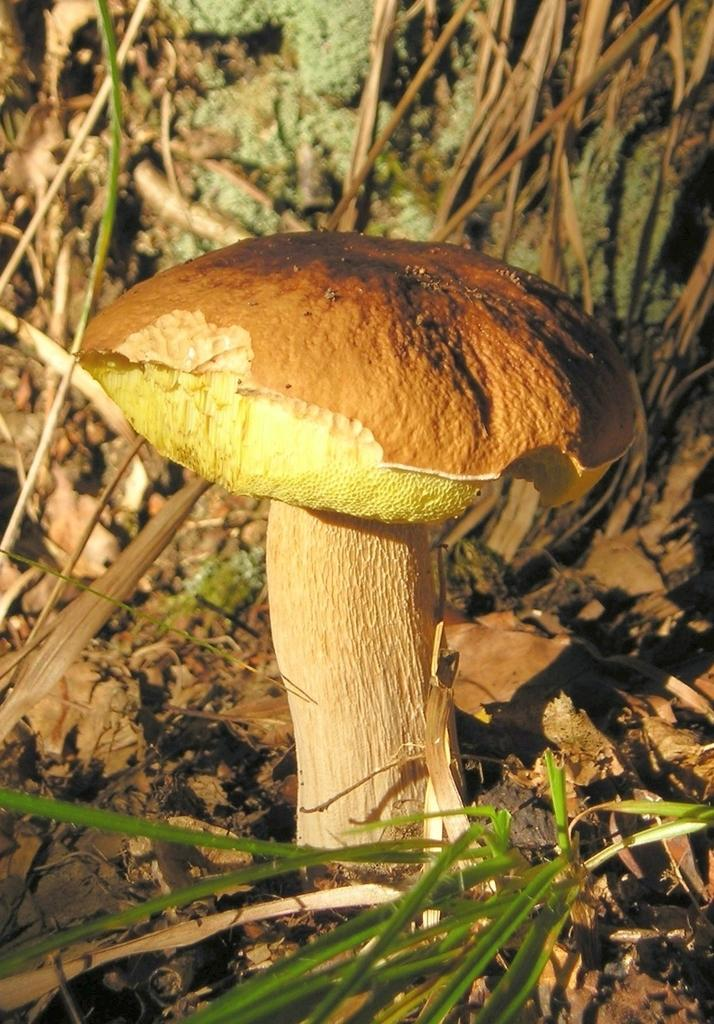What is the main subject of the image? There is a mushroom in the image. What colors can be seen on the mushroom? The mushroom has cream, green, and brown colors. Where is the mushroom located in the image? The mushroom is on the ground. What type of vegetation is visible in the image? There is grass visible in the image. What additional natural elements can be seen in the image? There are dried leaves in the image. How does the mushroom contribute to the local society in the image? The image does not depict a society or any social context, so it is not possible to determine how the mushroom might contribute to a local society. 